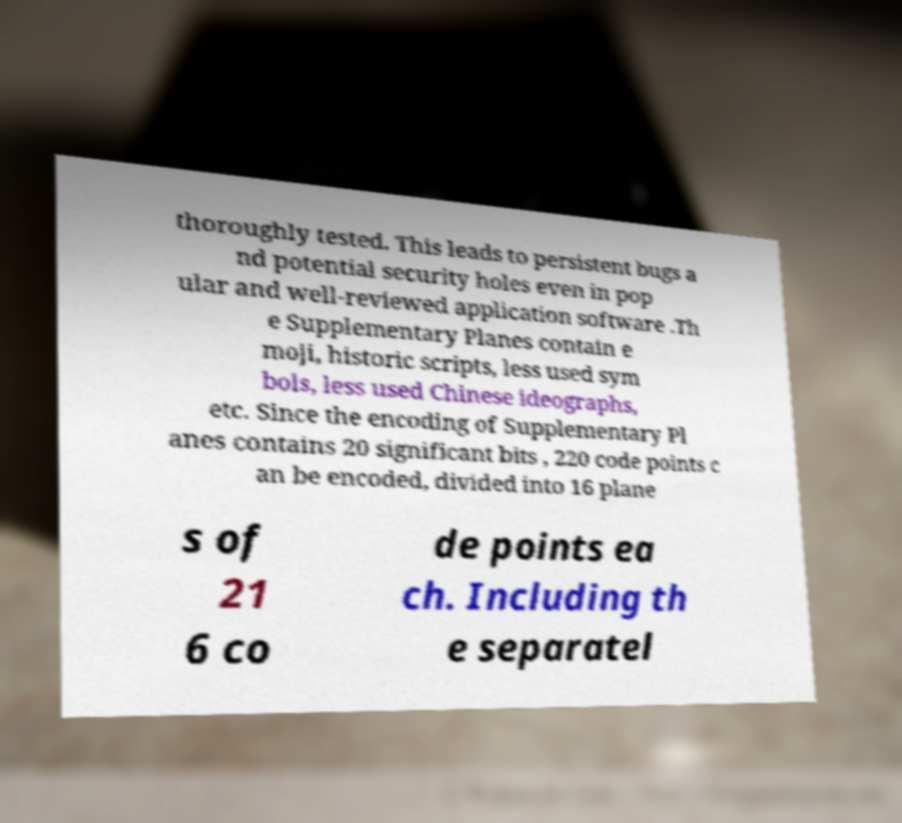What messages or text are displayed in this image? I need them in a readable, typed format. thoroughly tested. This leads to persistent bugs a nd potential security holes even in pop ular and well-reviewed application software .Th e Supplementary Planes contain e moji, historic scripts, less used sym bols, less used Chinese ideographs, etc. Since the encoding of Supplementary Pl anes contains 20 significant bits , 220 code points c an be encoded, divided into 16 plane s of 21 6 co de points ea ch. Including th e separatel 